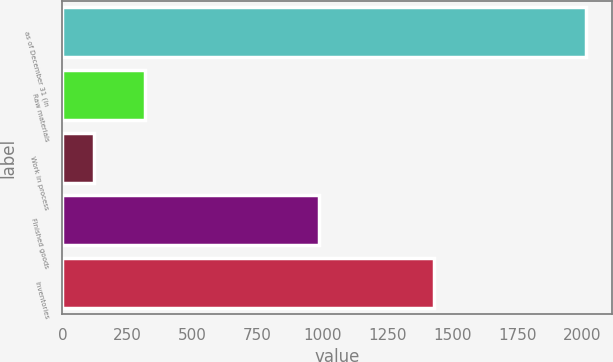Convert chart. <chart><loc_0><loc_0><loc_500><loc_500><bar_chart><fcel>as of December 31 (in<fcel>Raw materials<fcel>Work in process<fcel>Finished goods<fcel>Inventories<nl><fcel>2016<fcel>319<fcel>122<fcel>989<fcel>1430<nl></chart> 